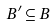<formula> <loc_0><loc_0><loc_500><loc_500>B ^ { \prime } \subseteq B</formula> 